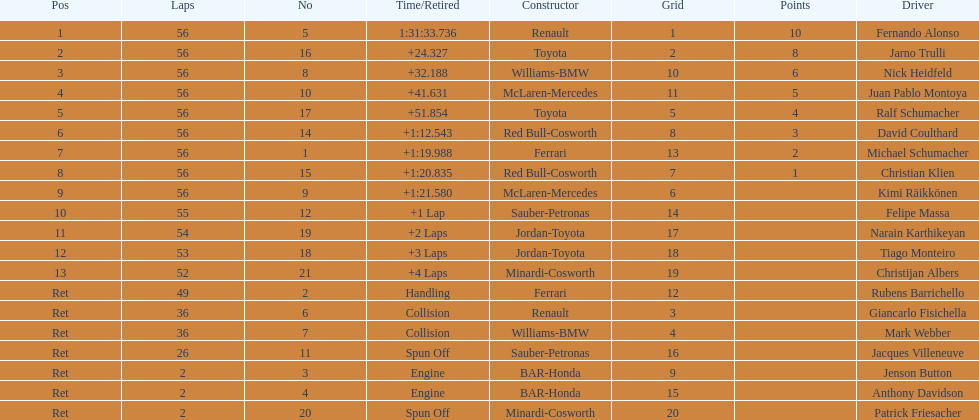Who finished before nick heidfeld? Jarno Trulli. 